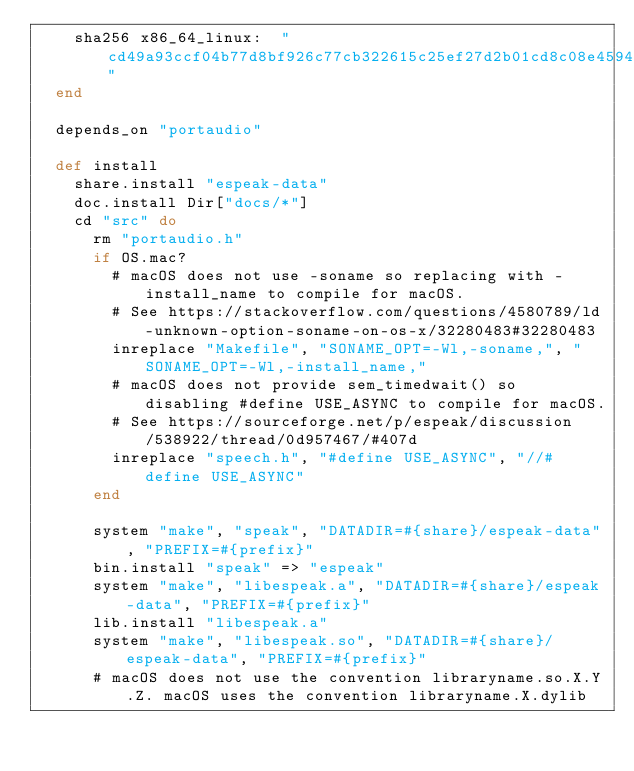<code> <loc_0><loc_0><loc_500><loc_500><_Ruby_>    sha256 x86_64_linux:  "cd49a93ccf04b77d8bf926c77cb322615c25ef27d2b01cd8c08e45945bd01183"
  end

  depends_on "portaudio"

  def install
    share.install "espeak-data"
    doc.install Dir["docs/*"]
    cd "src" do
      rm "portaudio.h"
      if OS.mac?
        # macOS does not use -soname so replacing with -install_name to compile for macOS.
        # See https://stackoverflow.com/questions/4580789/ld-unknown-option-soname-on-os-x/32280483#32280483
        inreplace "Makefile", "SONAME_OPT=-Wl,-soname,", "SONAME_OPT=-Wl,-install_name,"
        # macOS does not provide sem_timedwait() so disabling #define USE_ASYNC to compile for macOS.
        # See https://sourceforge.net/p/espeak/discussion/538922/thread/0d957467/#407d
        inreplace "speech.h", "#define USE_ASYNC", "//#define USE_ASYNC"
      end

      system "make", "speak", "DATADIR=#{share}/espeak-data", "PREFIX=#{prefix}"
      bin.install "speak" => "espeak"
      system "make", "libespeak.a", "DATADIR=#{share}/espeak-data", "PREFIX=#{prefix}"
      lib.install "libespeak.a"
      system "make", "libespeak.so", "DATADIR=#{share}/espeak-data", "PREFIX=#{prefix}"
      # macOS does not use the convention libraryname.so.X.Y.Z. macOS uses the convention libraryname.X.dylib</code> 